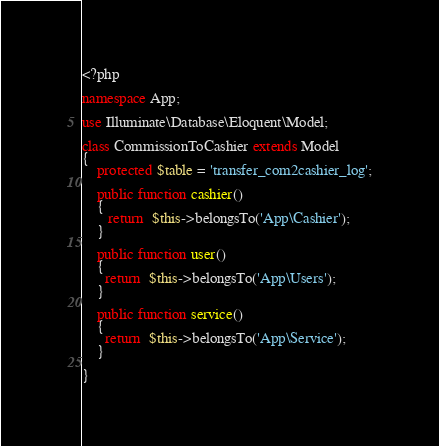Convert code to text. <code><loc_0><loc_0><loc_500><loc_500><_PHP_><?php

namespace App;

use Illuminate\Database\Eloquent\Model;

class CommissionToCashier extends Model
{
    protected $table = 'transfer_com2cashier_log';

    public function cashier()
    {
       return  $this->belongsTo('App\Cashier');
    }

    public function user()
    {
      return  $this->belongsTo('App\Users');
    }

    public function service()
    {
      return  $this->belongsTo('App\Service');
    }
   
}
</code> 